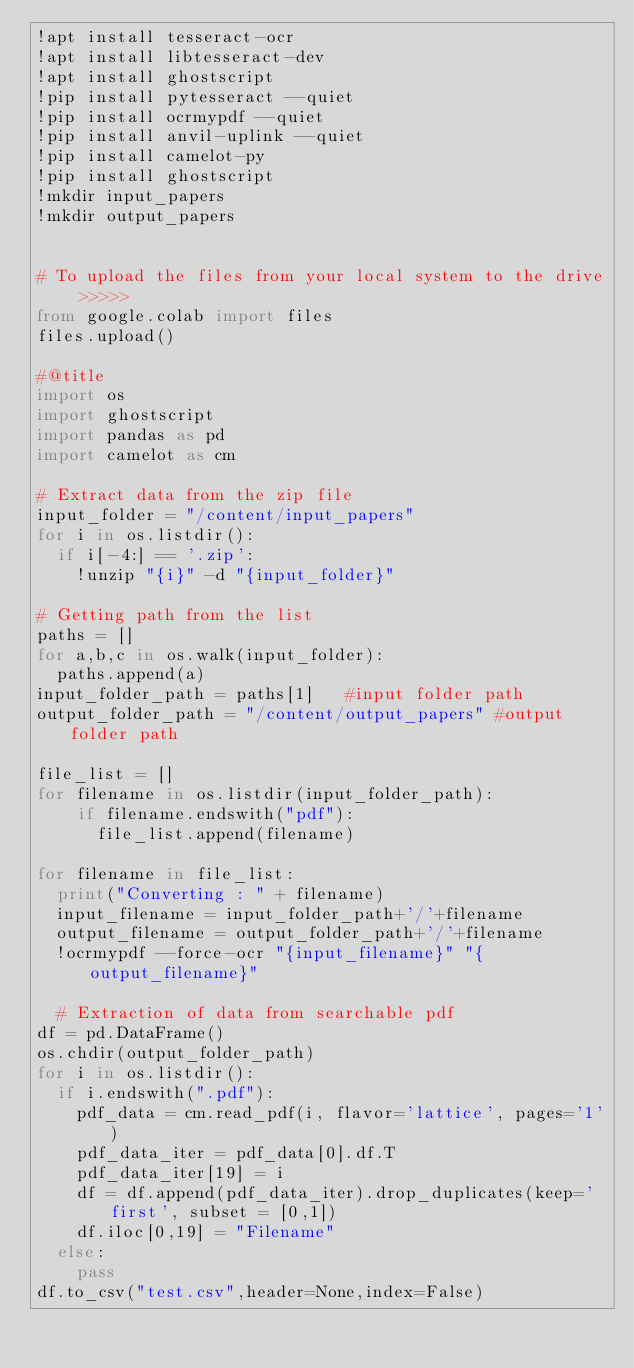<code> <loc_0><loc_0><loc_500><loc_500><_Python_>!apt install tesseract-ocr
!apt install libtesseract-dev
!apt install ghostscript
!pip install pytesseract --quiet
!pip install ocrmypdf --quiet
!pip install anvil-uplink --quiet
!pip install camelot-py
!pip install ghostscript
!mkdir input_papers
!mkdir output_papers


# To upload the files from your local system to the drive >>>>>
from google.colab import files
files.upload()

#@title
import os
import ghostscript
import pandas as pd
import camelot as cm

# Extract data from the zip file
input_folder = "/content/input_papers"
for i in os.listdir():
  if i[-4:] == '.zip':
    !unzip "{i}" -d "{input_folder}"

# Getting path from the list
paths = []
for a,b,c in os.walk(input_folder):
  paths.append(a)
input_folder_path = paths[1]   #input folder path
output_folder_path = "/content/output_papers" #output folder path

file_list = []
for filename in os.listdir(input_folder_path):
    if filename.endswith("pdf"): 
      file_list.append(filename)

for filename in file_list:
  print("Converting : " + filename)
  input_filename = input_folder_path+'/'+filename
  output_filename = output_folder_path+'/'+filename
  !ocrmypdf --force-ocr "{input_filename}" "{output_filename}"

  # Extraction of data from searchable pdf
df = pd.DataFrame()
os.chdir(output_folder_path)
for i in os.listdir():
  if i.endswith(".pdf"):
    pdf_data = cm.read_pdf(i, flavor='lattice', pages='1')
    pdf_data_iter = pdf_data[0].df.T
    pdf_data_iter[19] = i
    df = df.append(pdf_data_iter).drop_duplicates(keep='first', subset = [0,1])
    df.iloc[0,19] = "Filename"
  else:
    pass
df.to_csv("test.csv",header=None,index=False)
</code> 